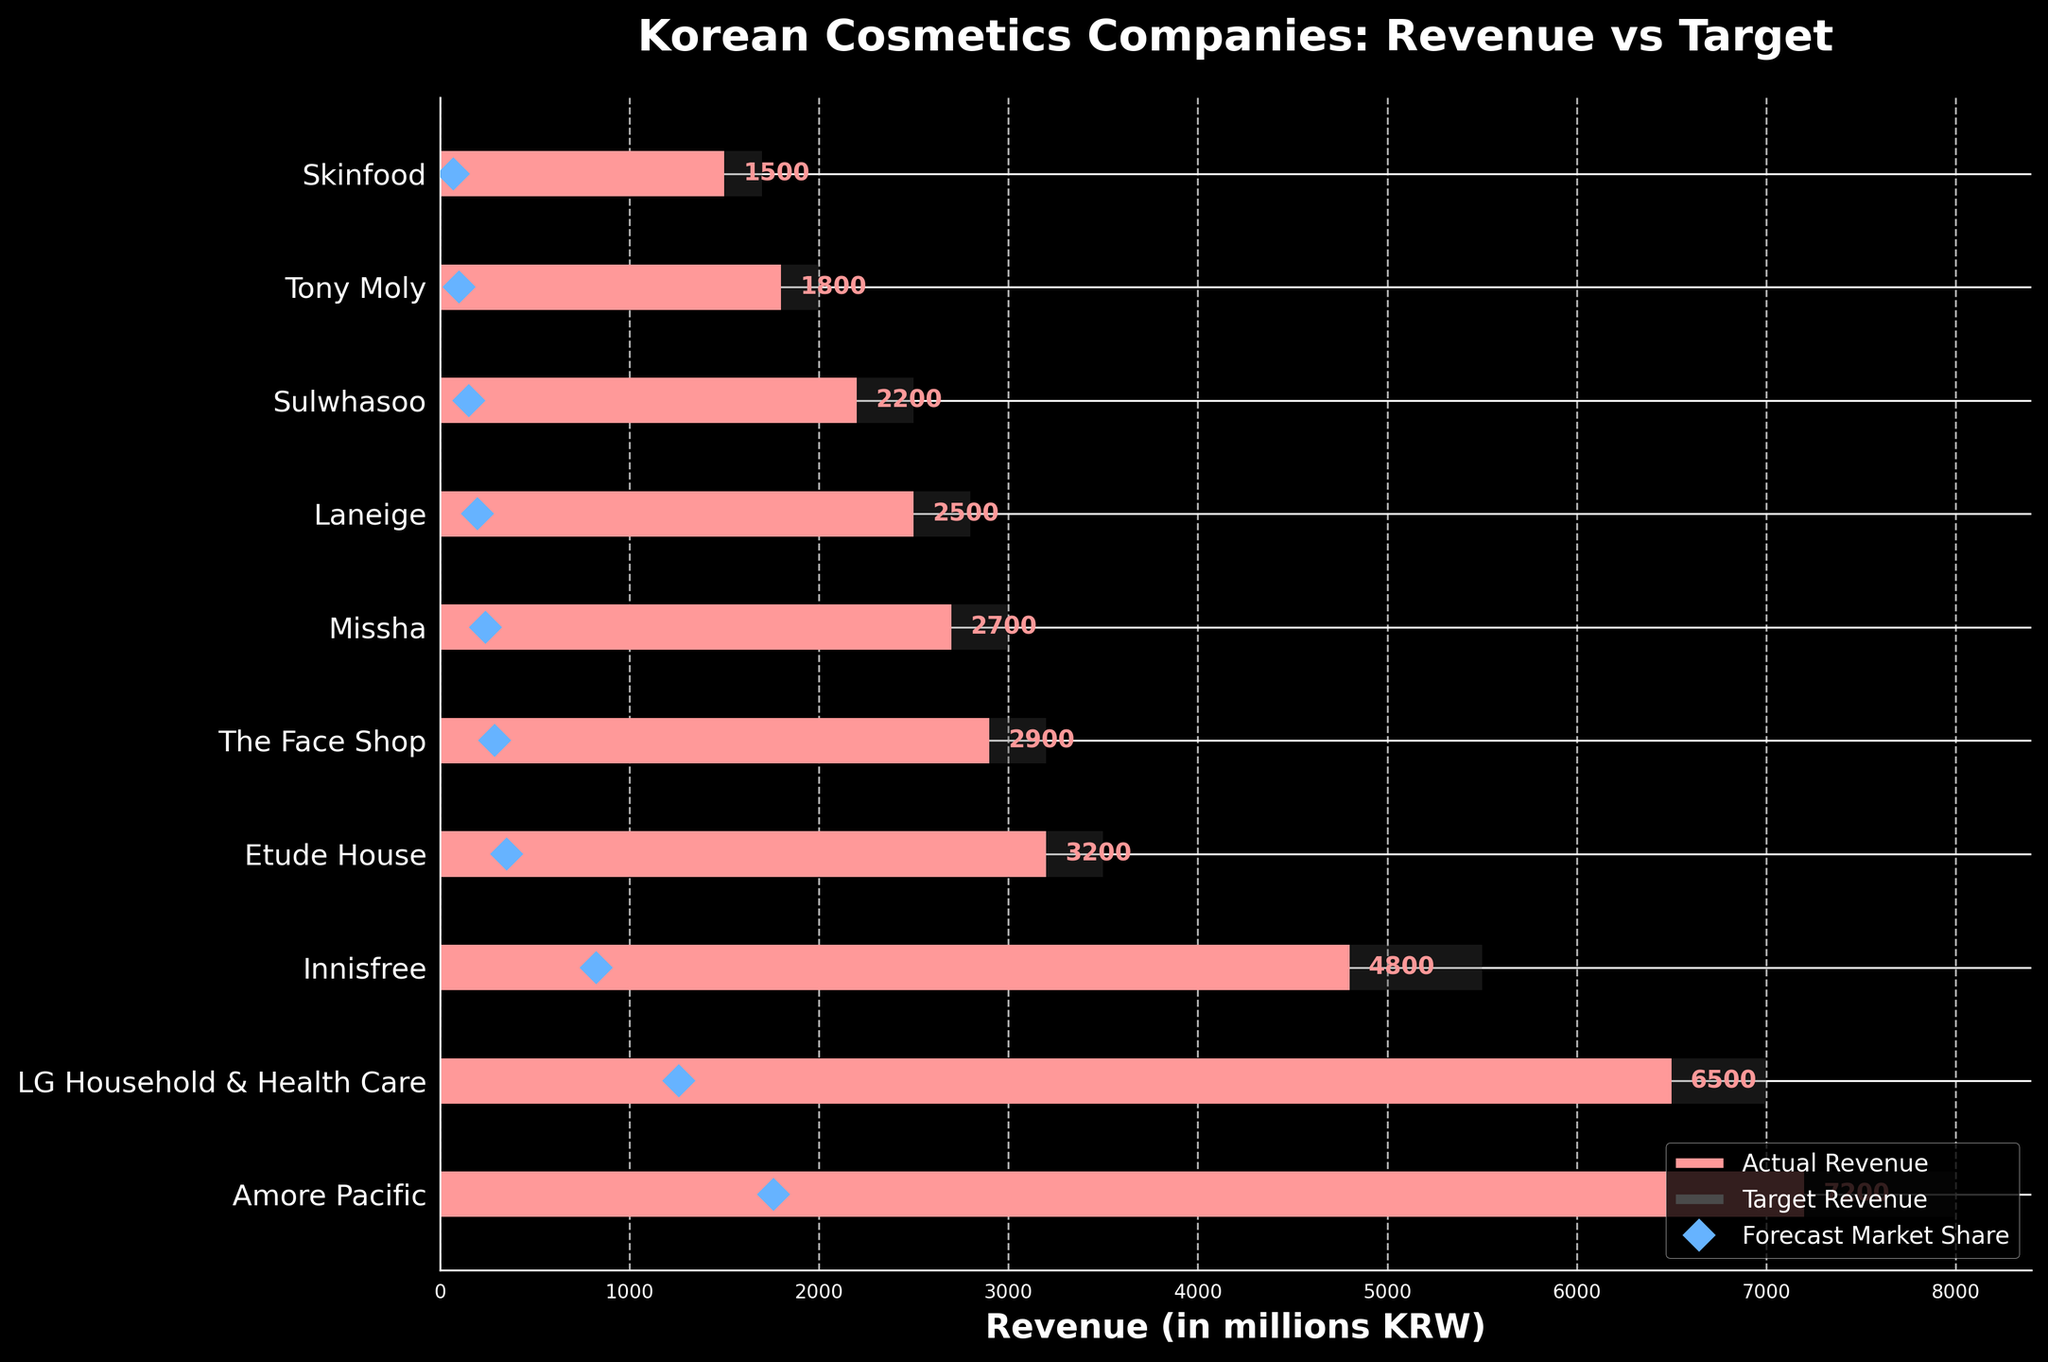What is the title of the figure? The title is usually placed at the top of the figure. It is meant to provide a summary of what the chart represents. In this case, it reads: 'Korean Cosmetics Companies: Revenue vs Target'.
Answer: Korean Cosmetics Companies: Revenue vs Target Which company has the highest actual revenue? To determine the company with the highest actual revenue, compare the bars representing actual revenue for each company. The longest bar corresponds to Amore Pacific at 7200 million KRW.
Answer: Amore Pacific What is the actual revenue of The Face Shop? Locate The Face Shop on the Y-axis and look at the length of its corresponding actual revenue bar. The label next to the bar indicates 2900 million KRW.
Answer: 2900 million KRW How many companies have their actual revenue less than their target revenue? Compare each company's actual revenue bar with its target revenue bar. If the actual bar is shorter than the target bar, count it. Companies with shorter bars are: Amore Pacific, LG Household & Health Care, Innisfree, Etude House, The Face Shop, Missha, and Sulwhasoo giving a total of 7.
Answer: 7 Which company comes closest to hitting its target revenue? Compare the actual and target bars for each company to find the smallest difference. The closest match is LG Household & Health Care with an actual revenue of 6500 and a target of 7000, a difference of 500.
Answer: LG Household & Health Care What is the forecasted market share for Laneige? Locate Laneige on the Y-axis and look at the blue diamond marker. According to the legend, this represents the forecast market share. For Laneige, it is 7%.
Answer: 7% Between Innisfree and Missha, which company has a higher actual revenue, and by how much? Compare the actual revenue bars for Innisfree and Missha. Innisfree has 4800 million KRW, and Missha has 2700 million KRW. The difference is 4800 - 2700 = 2100 million KRW.
Answer: Innisfree by 2100 million KRW How does Tony Moly's actual revenue compare to its forecast market share? Tony Moly has an actual revenue of 1800 million KRW. The forecast market share marker indicates 5%, and 2000 is the target revenue. The actual revenue falls short of the target and is not expected to meet the 5% market share.
Answer: It falls short Which companies' actual revenue exceeds their forecast market share? Compare each company's actual revenue with their respective forecast market share. Companies where actual revenue exceeds forecasted share include Amore Pacific and LG Household & Health Care since their actual revenue bars are quite longer compared to the location of the forecast share marker.
Answer: Amore Pacific, LG Household & Health Care Which company has the lowest actual revenue and what is it? Identify the shortest bar for actual revenue. This corresponds to Skinfood with an actual revenue of 1500 million KRW.
Answer: Skinfood at 1500 million KRW 